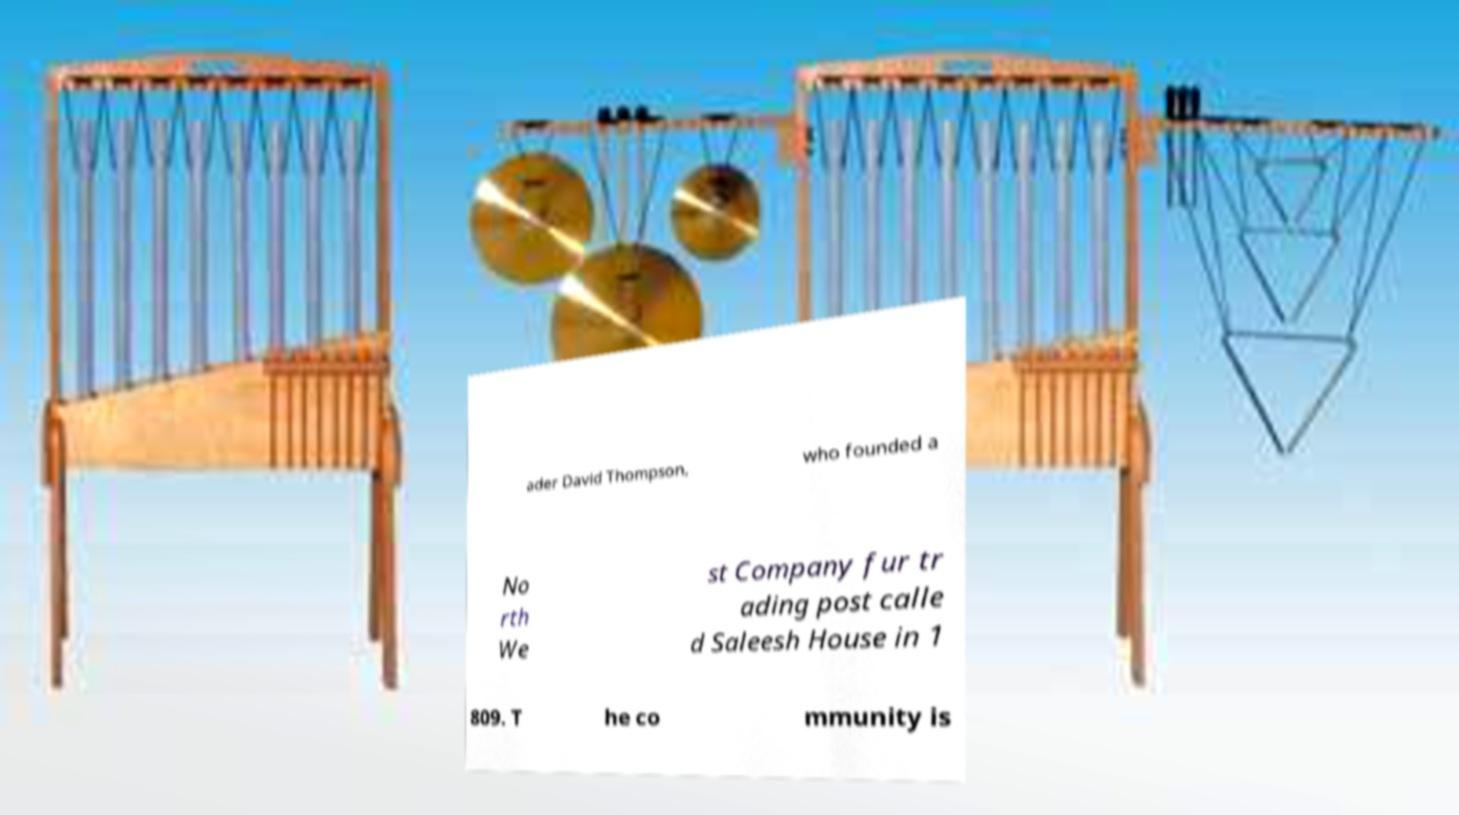Please identify and transcribe the text found in this image. ader David Thompson, who founded a No rth We st Company fur tr ading post calle d Saleesh House in 1 809. T he co mmunity is 